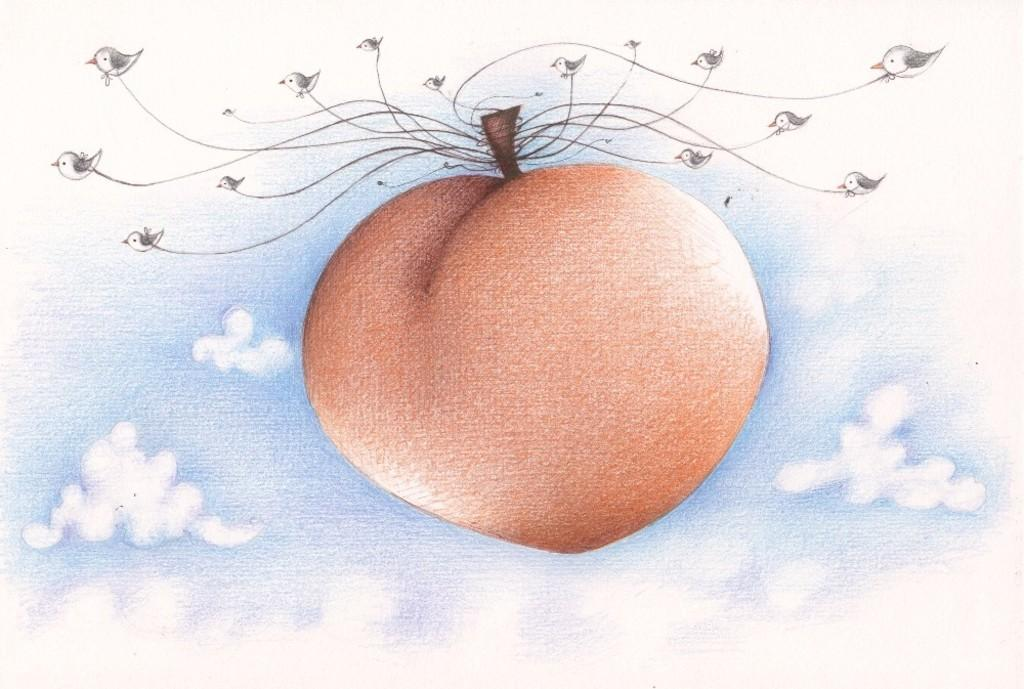What is the main subject of the image? There is a picture in the image. What can be seen in the picture? The picture contains sky with clouds. Are there any additional elements in the picture? Yes, threads are hanged in the picture. What type of humor can be seen in the picture? There is no humor present in the image, as it only contains a picture of sky with clouds and hanging threads. 